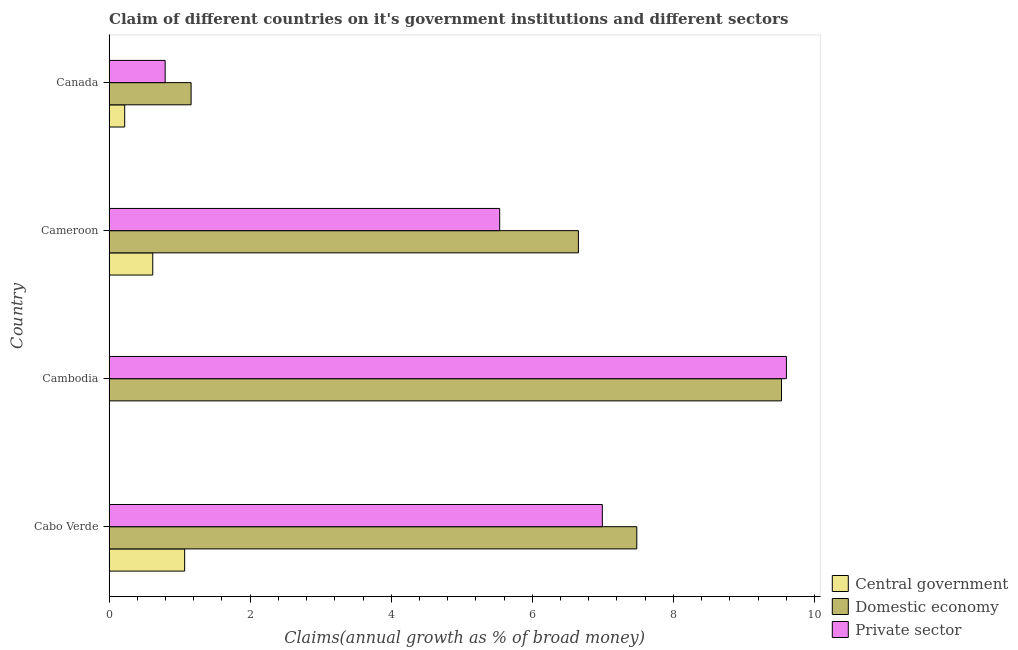How many different coloured bars are there?
Your response must be concise. 3. Are the number of bars per tick equal to the number of legend labels?
Your answer should be very brief. No. How many bars are there on the 2nd tick from the top?
Your answer should be compact. 3. How many bars are there on the 2nd tick from the bottom?
Give a very brief answer. 2. What is the label of the 3rd group of bars from the top?
Make the answer very short. Cambodia. In how many cases, is the number of bars for a given country not equal to the number of legend labels?
Provide a short and direct response. 1. What is the percentage of claim on the domestic economy in Cambodia?
Ensure brevity in your answer.  9.53. Across all countries, what is the maximum percentage of claim on the domestic economy?
Provide a succinct answer. 9.53. Across all countries, what is the minimum percentage of claim on the central government?
Your answer should be compact. 0. In which country was the percentage of claim on the central government maximum?
Offer a terse response. Cabo Verde. What is the total percentage of claim on the domestic economy in the graph?
Your answer should be compact. 24.83. What is the difference between the percentage of claim on the private sector in Cabo Verde and that in Cambodia?
Provide a succinct answer. -2.61. What is the difference between the percentage of claim on the private sector in Cameroon and the percentage of claim on the central government in Canada?
Provide a succinct answer. 5.32. What is the average percentage of claim on the domestic economy per country?
Offer a very short reply. 6.21. What is the difference between the percentage of claim on the private sector and percentage of claim on the central government in Cabo Verde?
Give a very brief answer. 5.92. What is the ratio of the percentage of claim on the central government in Cabo Verde to that in Cameroon?
Make the answer very short. 1.73. Is the percentage of claim on the domestic economy in Cabo Verde less than that in Cameroon?
Give a very brief answer. No. What is the difference between the highest and the second highest percentage of claim on the private sector?
Offer a very short reply. 2.61. What is the difference between the highest and the lowest percentage of claim on the domestic economy?
Your response must be concise. 8.37. In how many countries, is the percentage of claim on the private sector greater than the average percentage of claim on the private sector taken over all countries?
Provide a succinct answer. 2. Are all the bars in the graph horizontal?
Your answer should be compact. Yes. What is the difference between two consecutive major ticks on the X-axis?
Keep it short and to the point. 2. Where does the legend appear in the graph?
Your answer should be very brief. Bottom right. How many legend labels are there?
Offer a terse response. 3. What is the title of the graph?
Offer a very short reply. Claim of different countries on it's government institutions and different sectors. What is the label or title of the X-axis?
Provide a succinct answer. Claims(annual growth as % of broad money). What is the label or title of the Y-axis?
Make the answer very short. Country. What is the Claims(annual growth as % of broad money) in Central government in Cabo Verde?
Offer a very short reply. 1.07. What is the Claims(annual growth as % of broad money) of Domestic economy in Cabo Verde?
Your response must be concise. 7.48. What is the Claims(annual growth as % of broad money) in Private sector in Cabo Verde?
Offer a very short reply. 6.99. What is the Claims(annual growth as % of broad money) of Central government in Cambodia?
Give a very brief answer. 0. What is the Claims(annual growth as % of broad money) of Domestic economy in Cambodia?
Offer a terse response. 9.53. What is the Claims(annual growth as % of broad money) in Private sector in Cambodia?
Your answer should be compact. 9.6. What is the Claims(annual growth as % of broad money) in Central government in Cameroon?
Provide a short and direct response. 0.62. What is the Claims(annual growth as % of broad money) of Domestic economy in Cameroon?
Offer a very short reply. 6.65. What is the Claims(annual growth as % of broad money) in Private sector in Cameroon?
Keep it short and to the point. 5.54. What is the Claims(annual growth as % of broad money) in Central government in Canada?
Make the answer very short. 0.22. What is the Claims(annual growth as % of broad money) of Domestic economy in Canada?
Give a very brief answer. 1.16. What is the Claims(annual growth as % of broad money) in Private sector in Canada?
Offer a terse response. 0.79. Across all countries, what is the maximum Claims(annual growth as % of broad money) in Central government?
Provide a short and direct response. 1.07. Across all countries, what is the maximum Claims(annual growth as % of broad money) in Domestic economy?
Ensure brevity in your answer.  9.53. Across all countries, what is the maximum Claims(annual growth as % of broad money) in Private sector?
Offer a very short reply. 9.6. Across all countries, what is the minimum Claims(annual growth as % of broad money) in Domestic economy?
Ensure brevity in your answer.  1.16. Across all countries, what is the minimum Claims(annual growth as % of broad money) in Private sector?
Give a very brief answer. 0.79. What is the total Claims(annual growth as % of broad money) in Central government in the graph?
Ensure brevity in your answer.  1.91. What is the total Claims(annual growth as % of broad money) of Domestic economy in the graph?
Offer a very short reply. 24.83. What is the total Claims(annual growth as % of broad money) in Private sector in the graph?
Offer a terse response. 22.93. What is the difference between the Claims(annual growth as % of broad money) of Domestic economy in Cabo Verde and that in Cambodia?
Your answer should be compact. -2.05. What is the difference between the Claims(annual growth as % of broad money) of Private sector in Cabo Verde and that in Cambodia?
Offer a terse response. -2.61. What is the difference between the Claims(annual growth as % of broad money) in Central government in Cabo Verde and that in Cameroon?
Offer a terse response. 0.45. What is the difference between the Claims(annual growth as % of broad money) in Domestic economy in Cabo Verde and that in Cameroon?
Make the answer very short. 0.83. What is the difference between the Claims(annual growth as % of broad money) in Private sector in Cabo Verde and that in Cameroon?
Offer a terse response. 1.46. What is the difference between the Claims(annual growth as % of broad money) of Central government in Cabo Verde and that in Canada?
Your response must be concise. 0.85. What is the difference between the Claims(annual growth as % of broad money) of Domestic economy in Cabo Verde and that in Canada?
Offer a very short reply. 6.32. What is the difference between the Claims(annual growth as % of broad money) in Private sector in Cabo Verde and that in Canada?
Make the answer very short. 6.2. What is the difference between the Claims(annual growth as % of broad money) of Domestic economy in Cambodia and that in Cameroon?
Your answer should be very brief. 2.88. What is the difference between the Claims(annual growth as % of broad money) in Private sector in Cambodia and that in Cameroon?
Provide a succinct answer. 4.06. What is the difference between the Claims(annual growth as % of broad money) of Domestic economy in Cambodia and that in Canada?
Give a very brief answer. 8.37. What is the difference between the Claims(annual growth as % of broad money) in Private sector in Cambodia and that in Canada?
Your response must be concise. 8.81. What is the difference between the Claims(annual growth as % of broad money) in Central government in Cameroon and that in Canada?
Provide a succinct answer. 0.4. What is the difference between the Claims(annual growth as % of broad money) in Domestic economy in Cameroon and that in Canada?
Offer a terse response. 5.49. What is the difference between the Claims(annual growth as % of broad money) of Private sector in Cameroon and that in Canada?
Offer a terse response. 4.74. What is the difference between the Claims(annual growth as % of broad money) in Central government in Cabo Verde and the Claims(annual growth as % of broad money) in Domestic economy in Cambodia?
Your answer should be compact. -8.46. What is the difference between the Claims(annual growth as % of broad money) in Central government in Cabo Verde and the Claims(annual growth as % of broad money) in Private sector in Cambodia?
Your response must be concise. -8.53. What is the difference between the Claims(annual growth as % of broad money) in Domestic economy in Cabo Verde and the Claims(annual growth as % of broad money) in Private sector in Cambodia?
Provide a succinct answer. -2.12. What is the difference between the Claims(annual growth as % of broad money) of Central government in Cabo Verde and the Claims(annual growth as % of broad money) of Domestic economy in Cameroon?
Your answer should be very brief. -5.58. What is the difference between the Claims(annual growth as % of broad money) in Central government in Cabo Verde and the Claims(annual growth as % of broad money) in Private sector in Cameroon?
Offer a very short reply. -4.47. What is the difference between the Claims(annual growth as % of broad money) in Domestic economy in Cabo Verde and the Claims(annual growth as % of broad money) in Private sector in Cameroon?
Your answer should be compact. 1.94. What is the difference between the Claims(annual growth as % of broad money) in Central government in Cabo Verde and the Claims(annual growth as % of broad money) in Domestic economy in Canada?
Offer a terse response. -0.09. What is the difference between the Claims(annual growth as % of broad money) in Central government in Cabo Verde and the Claims(annual growth as % of broad money) in Private sector in Canada?
Your answer should be very brief. 0.28. What is the difference between the Claims(annual growth as % of broad money) in Domestic economy in Cabo Verde and the Claims(annual growth as % of broad money) in Private sector in Canada?
Keep it short and to the point. 6.69. What is the difference between the Claims(annual growth as % of broad money) of Domestic economy in Cambodia and the Claims(annual growth as % of broad money) of Private sector in Cameroon?
Keep it short and to the point. 4. What is the difference between the Claims(annual growth as % of broad money) in Domestic economy in Cambodia and the Claims(annual growth as % of broad money) in Private sector in Canada?
Provide a succinct answer. 8.74. What is the difference between the Claims(annual growth as % of broad money) in Central government in Cameroon and the Claims(annual growth as % of broad money) in Domestic economy in Canada?
Offer a terse response. -0.54. What is the difference between the Claims(annual growth as % of broad money) of Central government in Cameroon and the Claims(annual growth as % of broad money) of Private sector in Canada?
Provide a succinct answer. -0.18. What is the difference between the Claims(annual growth as % of broad money) of Domestic economy in Cameroon and the Claims(annual growth as % of broad money) of Private sector in Canada?
Your response must be concise. 5.86. What is the average Claims(annual growth as % of broad money) of Central government per country?
Keep it short and to the point. 0.48. What is the average Claims(annual growth as % of broad money) of Domestic economy per country?
Ensure brevity in your answer.  6.21. What is the average Claims(annual growth as % of broad money) in Private sector per country?
Your response must be concise. 5.73. What is the difference between the Claims(annual growth as % of broad money) of Central government and Claims(annual growth as % of broad money) of Domestic economy in Cabo Verde?
Offer a terse response. -6.41. What is the difference between the Claims(annual growth as % of broad money) in Central government and Claims(annual growth as % of broad money) in Private sector in Cabo Verde?
Offer a terse response. -5.92. What is the difference between the Claims(annual growth as % of broad money) in Domestic economy and Claims(annual growth as % of broad money) in Private sector in Cabo Verde?
Provide a short and direct response. 0.49. What is the difference between the Claims(annual growth as % of broad money) of Domestic economy and Claims(annual growth as % of broad money) of Private sector in Cambodia?
Make the answer very short. -0.07. What is the difference between the Claims(annual growth as % of broad money) of Central government and Claims(annual growth as % of broad money) of Domestic economy in Cameroon?
Offer a terse response. -6.03. What is the difference between the Claims(annual growth as % of broad money) in Central government and Claims(annual growth as % of broad money) in Private sector in Cameroon?
Ensure brevity in your answer.  -4.92. What is the difference between the Claims(annual growth as % of broad money) in Domestic economy and Claims(annual growth as % of broad money) in Private sector in Cameroon?
Provide a succinct answer. 1.12. What is the difference between the Claims(annual growth as % of broad money) in Central government and Claims(annual growth as % of broad money) in Domestic economy in Canada?
Your response must be concise. -0.94. What is the difference between the Claims(annual growth as % of broad money) of Central government and Claims(annual growth as % of broad money) of Private sector in Canada?
Ensure brevity in your answer.  -0.57. What is the difference between the Claims(annual growth as % of broad money) of Domestic economy and Claims(annual growth as % of broad money) of Private sector in Canada?
Provide a short and direct response. 0.37. What is the ratio of the Claims(annual growth as % of broad money) in Domestic economy in Cabo Verde to that in Cambodia?
Your response must be concise. 0.78. What is the ratio of the Claims(annual growth as % of broad money) of Private sector in Cabo Verde to that in Cambodia?
Your response must be concise. 0.73. What is the ratio of the Claims(annual growth as % of broad money) in Central government in Cabo Verde to that in Cameroon?
Offer a very short reply. 1.73. What is the ratio of the Claims(annual growth as % of broad money) in Domestic economy in Cabo Verde to that in Cameroon?
Ensure brevity in your answer.  1.12. What is the ratio of the Claims(annual growth as % of broad money) in Private sector in Cabo Verde to that in Cameroon?
Make the answer very short. 1.26. What is the ratio of the Claims(annual growth as % of broad money) of Central government in Cabo Verde to that in Canada?
Provide a succinct answer. 4.83. What is the ratio of the Claims(annual growth as % of broad money) of Domestic economy in Cabo Verde to that in Canada?
Your answer should be compact. 6.43. What is the ratio of the Claims(annual growth as % of broad money) in Private sector in Cabo Verde to that in Canada?
Keep it short and to the point. 8.8. What is the ratio of the Claims(annual growth as % of broad money) of Domestic economy in Cambodia to that in Cameroon?
Your answer should be compact. 1.43. What is the ratio of the Claims(annual growth as % of broad money) of Private sector in Cambodia to that in Cameroon?
Provide a short and direct response. 1.73. What is the ratio of the Claims(annual growth as % of broad money) in Domestic economy in Cambodia to that in Canada?
Make the answer very short. 8.2. What is the ratio of the Claims(annual growth as % of broad money) in Private sector in Cambodia to that in Canada?
Offer a terse response. 12.08. What is the ratio of the Claims(annual growth as % of broad money) in Central government in Cameroon to that in Canada?
Your answer should be very brief. 2.79. What is the ratio of the Claims(annual growth as % of broad money) of Domestic economy in Cameroon to that in Canada?
Your answer should be compact. 5.72. What is the ratio of the Claims(annual growth as % of broad money) of Private sector in Cameroon to that in Canada?
Make the answer very short. 6.97. What is the difference between the highest and the second highest Claims(annual growth as % of broad money) in Central government?
Offer a very short reply. 0.45. What is the difference between the highest and the second highest Claims(annual growth as % of broad money) of Domestic economy?
Offer a terse response. 2.05. What is the difference between the highest and the second highest Claims(annual growth as % of broad money) in Private sector?
Your answer should be compact. 2.61. What is the difference between the highest and the lowest Claims(annual growth as % of broad money) of Central government?
Your answer should be very brief. 1.07. What is the difference between the highest and the lowest Claims(annual growth as % of broad money) of Domestic economy?
Make the answer very short. 8.37. What is the difference between the highest and the lowest Claims(annual growth as % of broad money) of Private sector?
Keep it short and to the point. 8.81. 